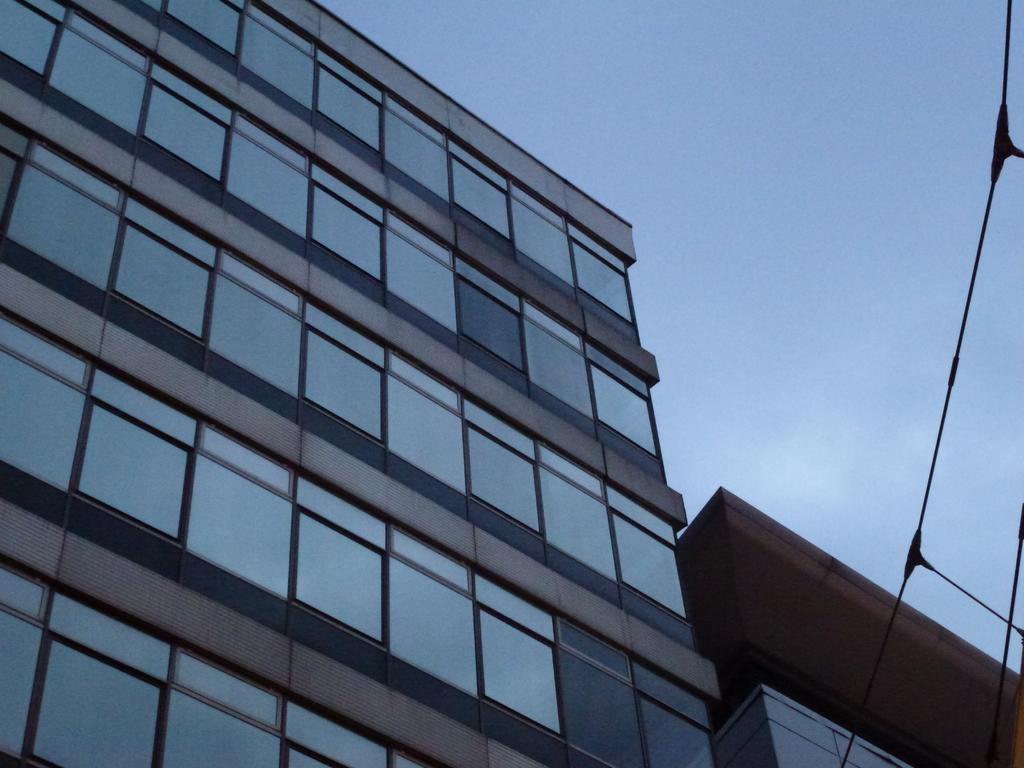Please provide a concise description of this image. On the left side of the image there is a building. In the background there is a sky. 